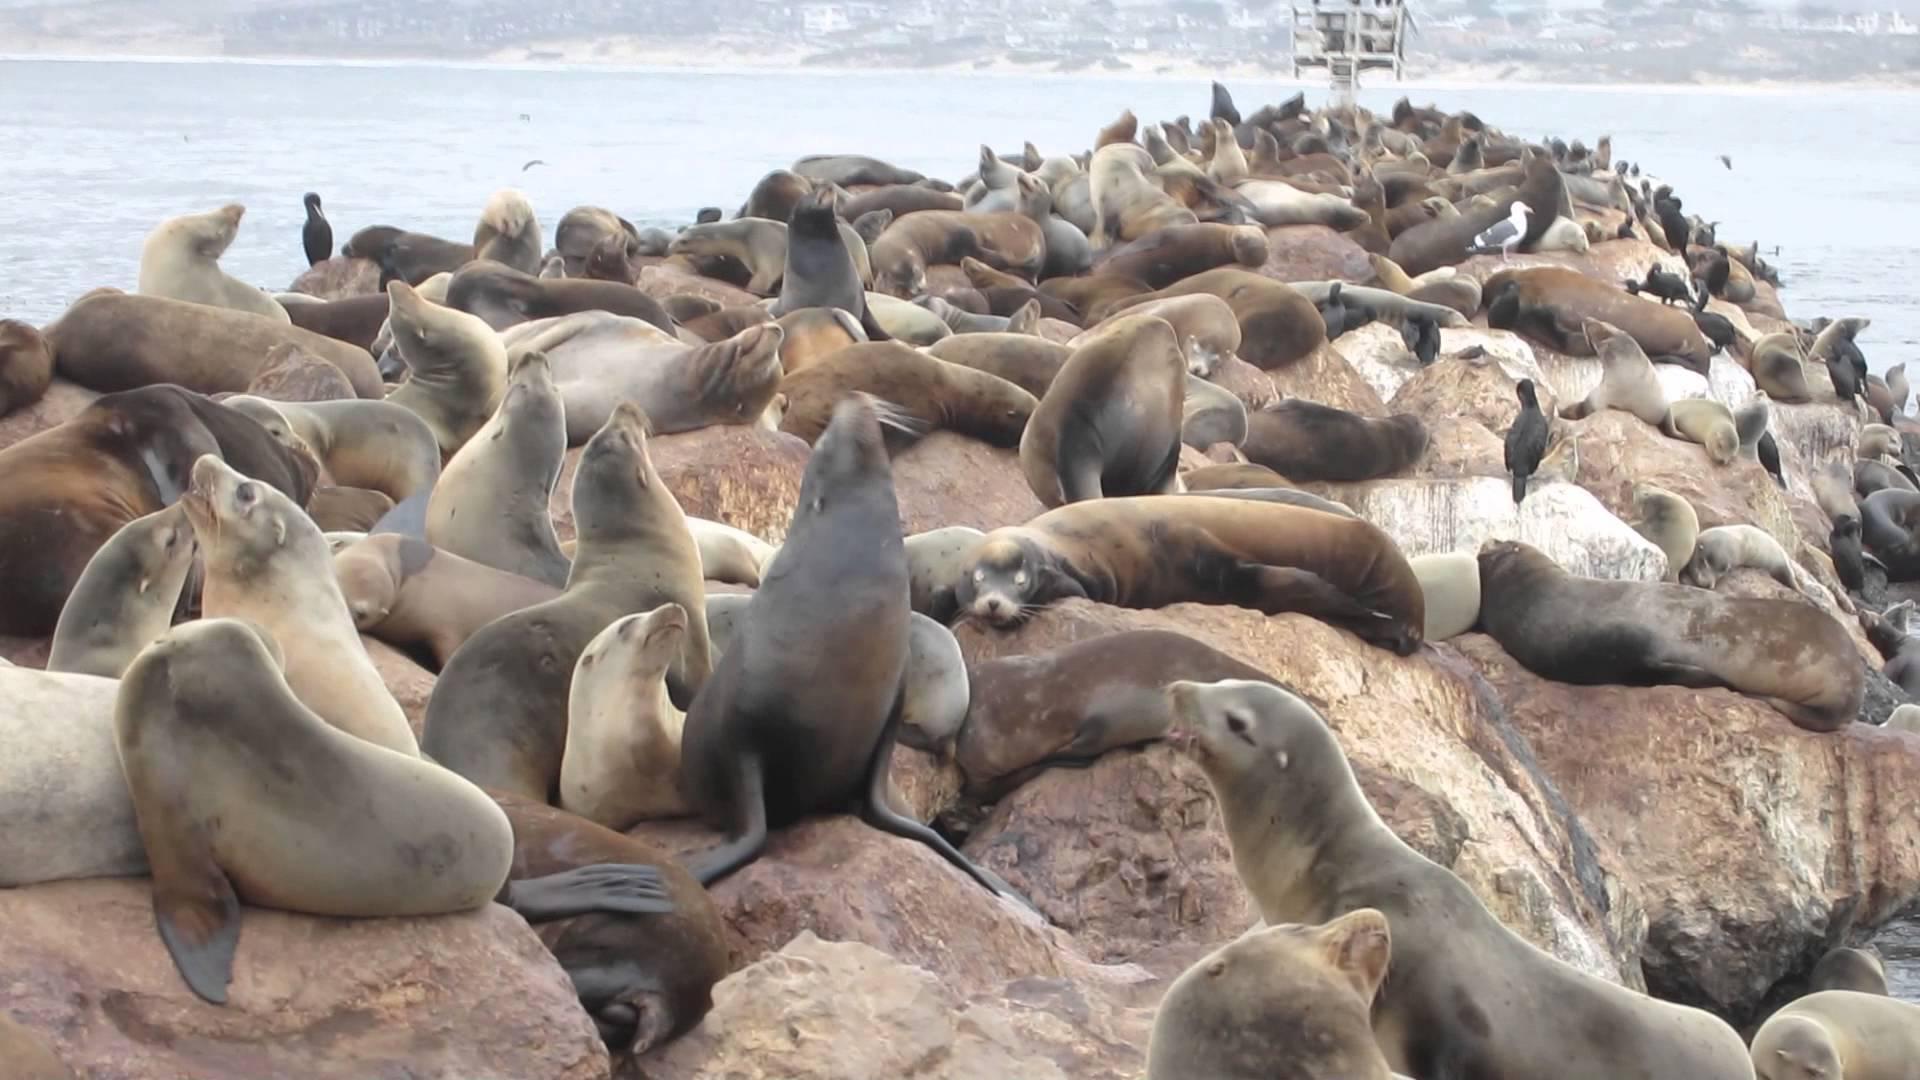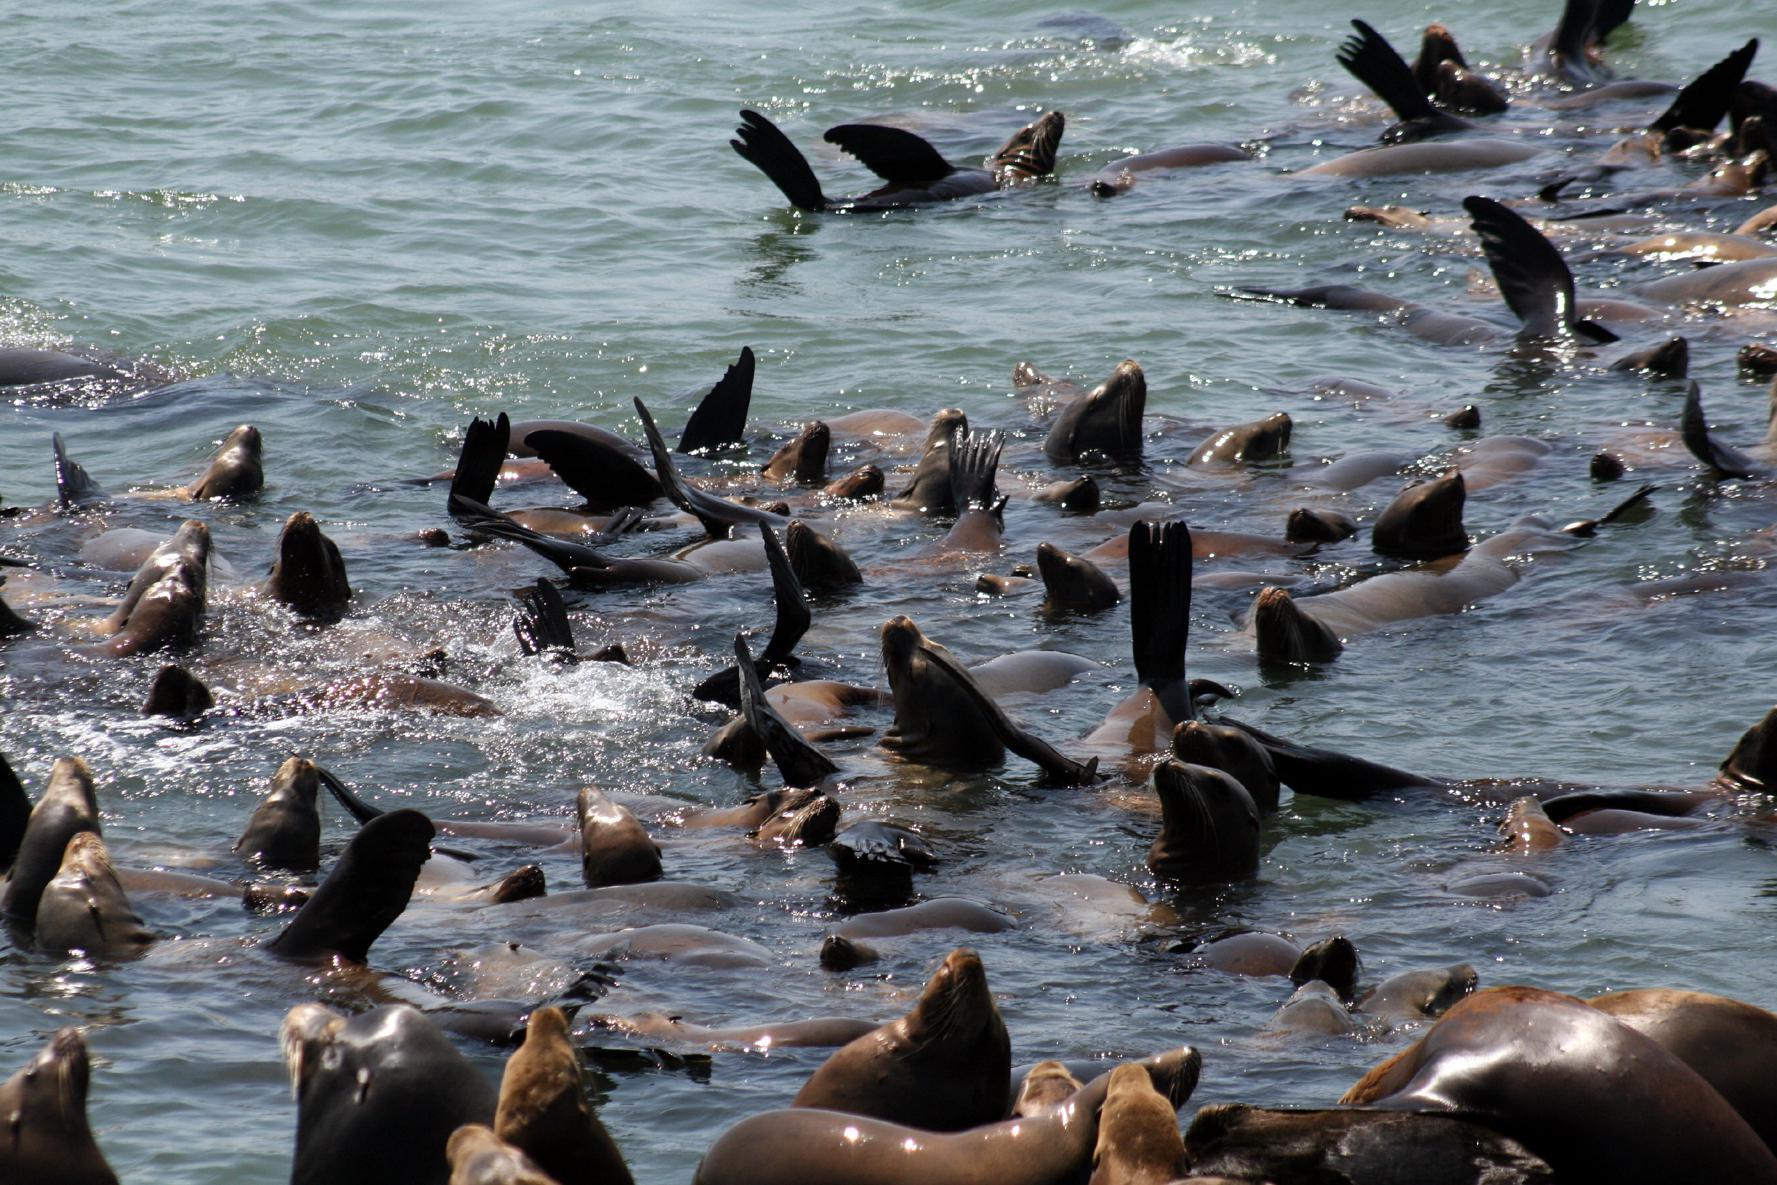The first image is the image on the left, the second image is the image on the right. Assess this claim about the two images: "Some of the sea lions are swimming in open water.". Correct or not? Answer yes or no. Yes. 